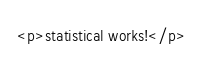<code> <loc_0><loc_0><loc_500><loc_500><_HTML_><p>statistical works!</p>
</code> 